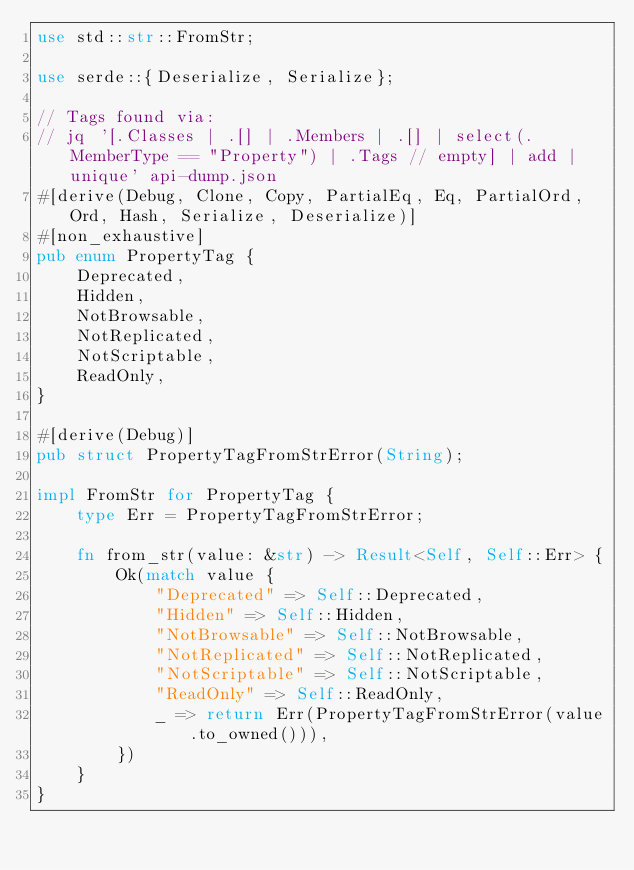Convert code to text. <code><loc_0><loc_0><loc_500><loc_500><_Rust_>use std::str::FromStr;

use serde::{Deserialize, Serialize};

// Tags found via:
// jq '[.Classes | .[] | .Members | .[] | select(.MemberType == "Property") | .Tags // empty] | add | unique' api-dump.json
#[derive(Debug, Clone, Copy, PartialEq, Eq, PartialOrd, Ord, Hash, Serialize, Deserialize)]
#[non_exhaustive]
pub enum PropertyTag {
    Deprecated,
    Hidden,
    NotBrowsable,
    NotReplicated,
    NotScriptable,
    ReadOnly,
}

#[derive(Debug)]
pub struct PropertyTagFromStrError(String);

impl FromStr for PropertyTag {
    type Err = PropertyTagFromStrError;

    fn from_str(value: &str) -> Result<Self, Self::Err> {
        Ok(match value {
            "Deprecated" => Self::Deprecated,
            "Hidden" => Self::Hidden,
            "NotBrowsable" => Self::NotBrowsable,
            "NotReplicated" => Self::NotReplicated,
            "NotScriptable" => Self::NotScriptable,
            "ReadOnly" => Self::ReadOnly,
            _ => return Err(PropertyTagFromStrError(value.to_owned())),
        })
    }
}
</code> 